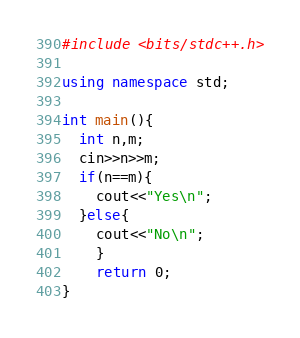<code> <loc_0><loc_0><loc_500><loc_500><_C++_>#include <bits/stdc++.h>
 
using namespace std;
 
int main(){
  int n,m;
  cin>>n>>m;
  if(n==m){
	cout<<"Yes\n";
  }else{
	cout<<"No\n";
	}
    return 0;
}</code> 